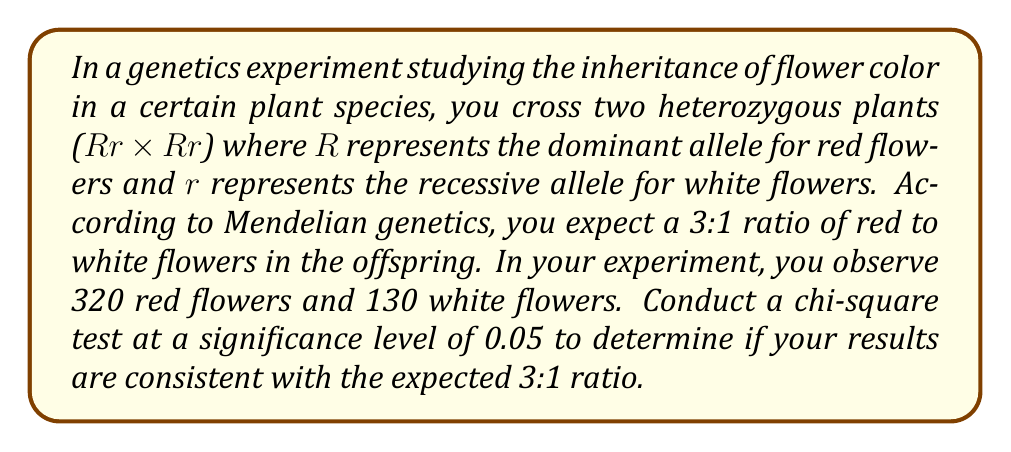Can you solve this math problem? To conduct a chi-square test, we'll follow these steps:

1. State the null and alternative hypotheses:
   $H_0$: The observed ratio fits the expected 3:1 ratio
   $H_a$: The observed ratio does not fit the expected 3:1 ratio

2. Calculate the expected frequencies:
   Total offspring: 320 + 130 = 450
   Expected red: 450 * 3/4 = 337.5
   Expected white: 450 * 1/4 = 112.5

3. Calculate the chi-square statistic:
   $\chi^2 = \sum\frac{(O - E)^2}{E}$

   For red flowers: $\frac{(320 - 337.5)^2}{337.5} = 0.9074$
   For white flowers: $\frac{(130 - 112.5)^2}{112.5} = 2.7222$

   $\chi^2 = 0.9074 + 2.7222 = 3.6296$

4. Determine the degrees of freedom:
   df = number of categories - 1 = 2 - 1 = 1

5. Find the critical value:
   For $\alpha = 0.05$ and df = 1, the critical value is 3.841

6. Compare the calculated $\chi^2$ to the critical value:
   $3.6296 < 3.841$

7. Calculate the p-value:
   Using a chi-square distribution calculator, we find p ≈ 0.0568

Since the calculated $\chi^2$ is less than the critical value and p > 0.05, we fail to reject the null hypothesis. This means that the observed results are consistent with the expected 3:1 ratio, and any deviation can be attributed to random chance.
Answer: Fail to reject $H_0$; $\chi^2 = 3.6296$, p ≈ 0.0568 